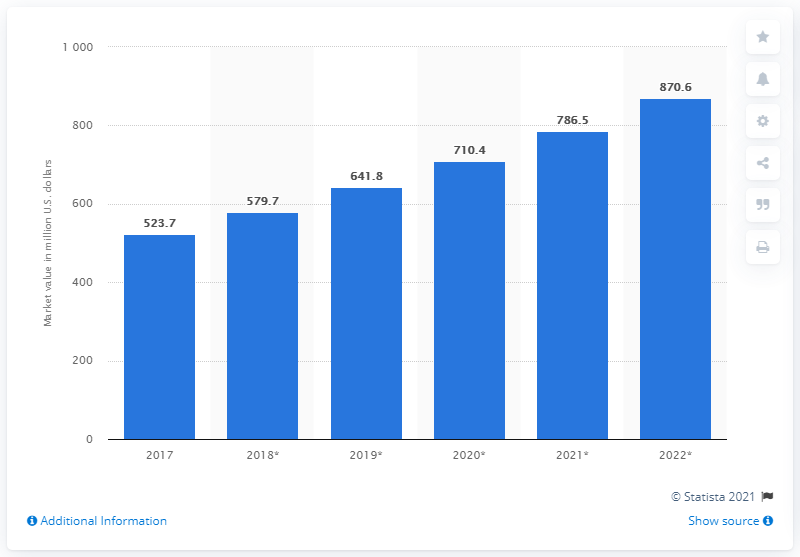Point out several critical features in this image. The value of the global aquaponics market in 2017 was 523.7 million dollars. The global aquaponics market is expected to grow at a significant rate by 2022, with a forecast of 870.6 million USD. 